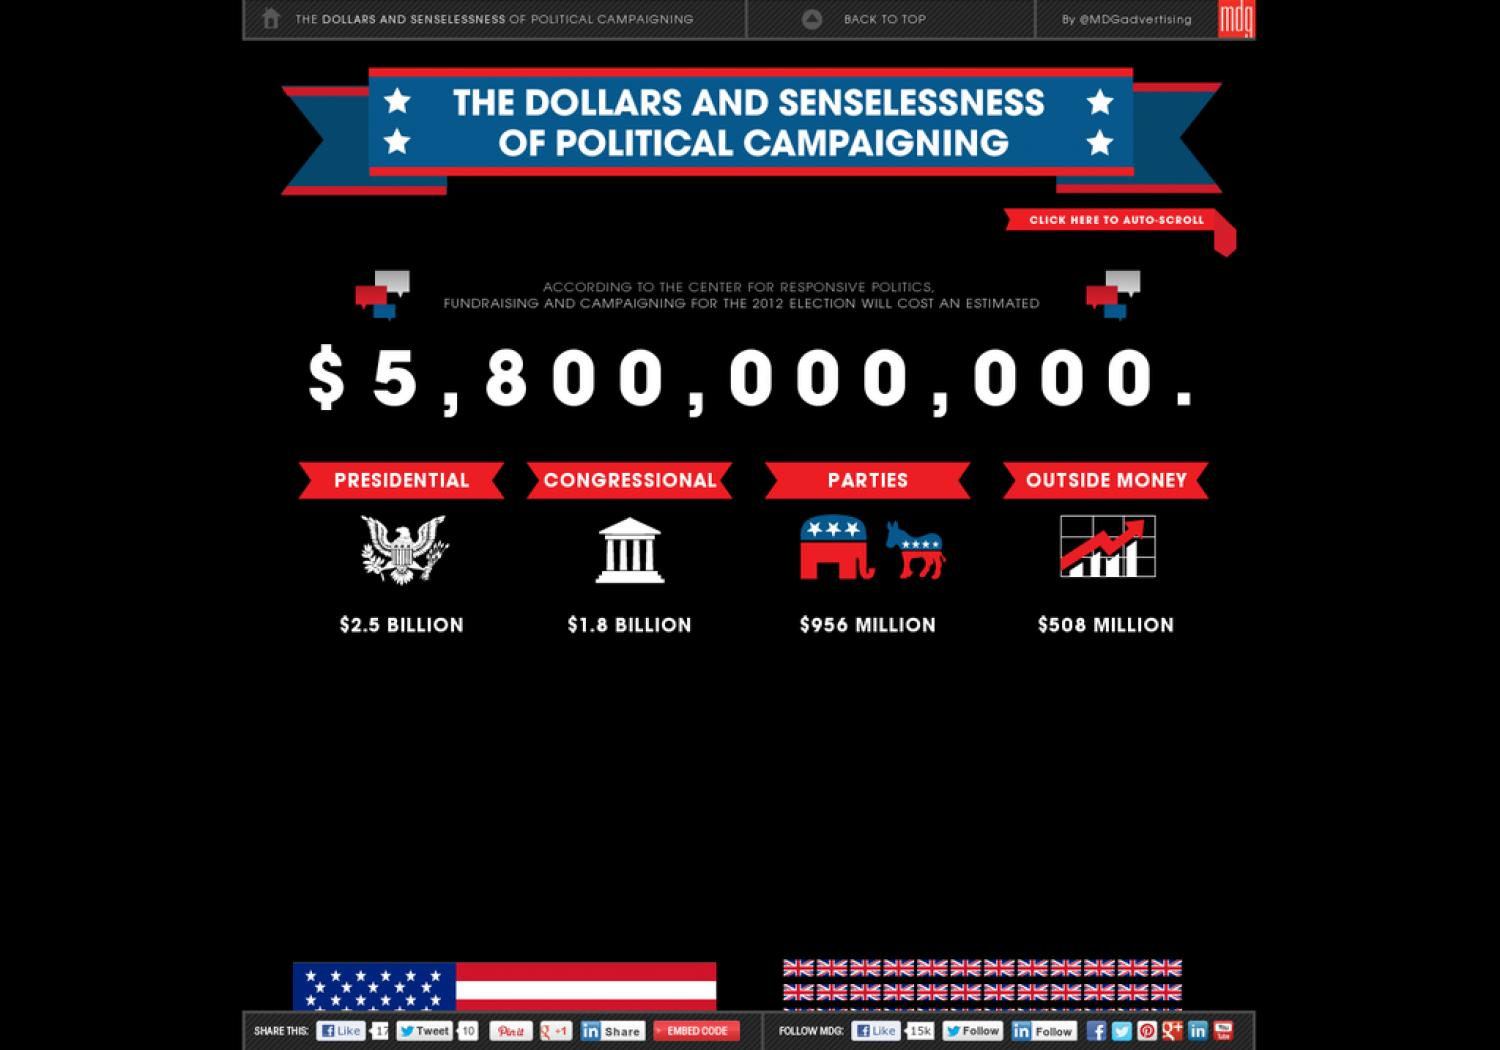Outline some significant characteristics in this image. A total of $508 million is expected to be spent on campaigning by outside groups in the 2020 election. Billions of dollars are spent in various areas, including presidential and congressional affairs. According to the data, $956 million is the amount of money spent by parties. 